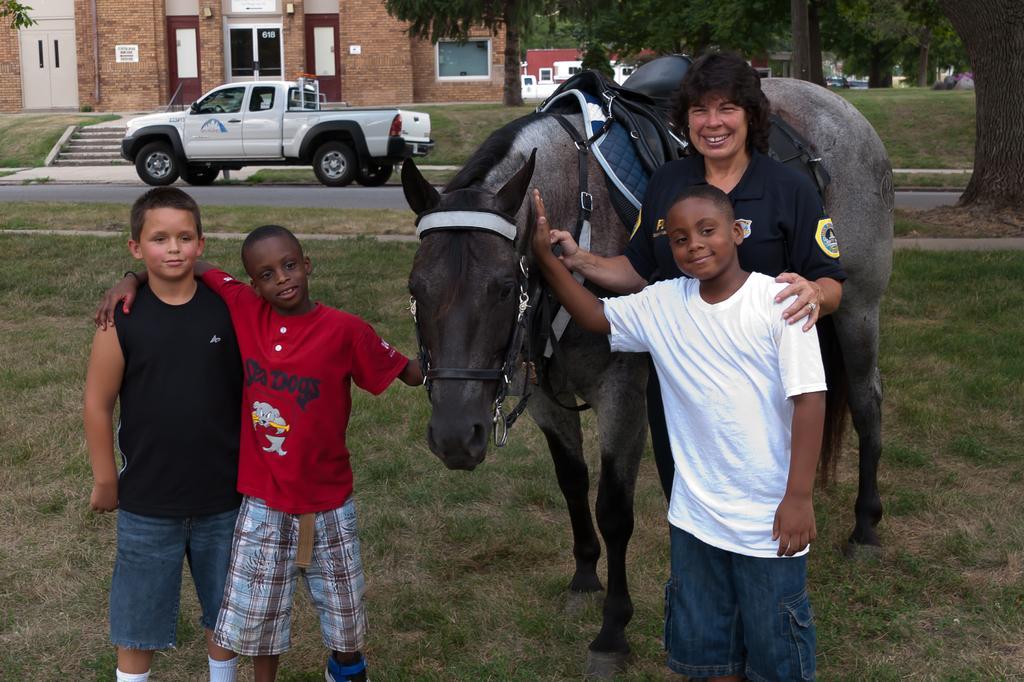Please provide a concise description of this image. In this image we can see this three persons are holding a horse. In the background we can see a car, trees and building. 